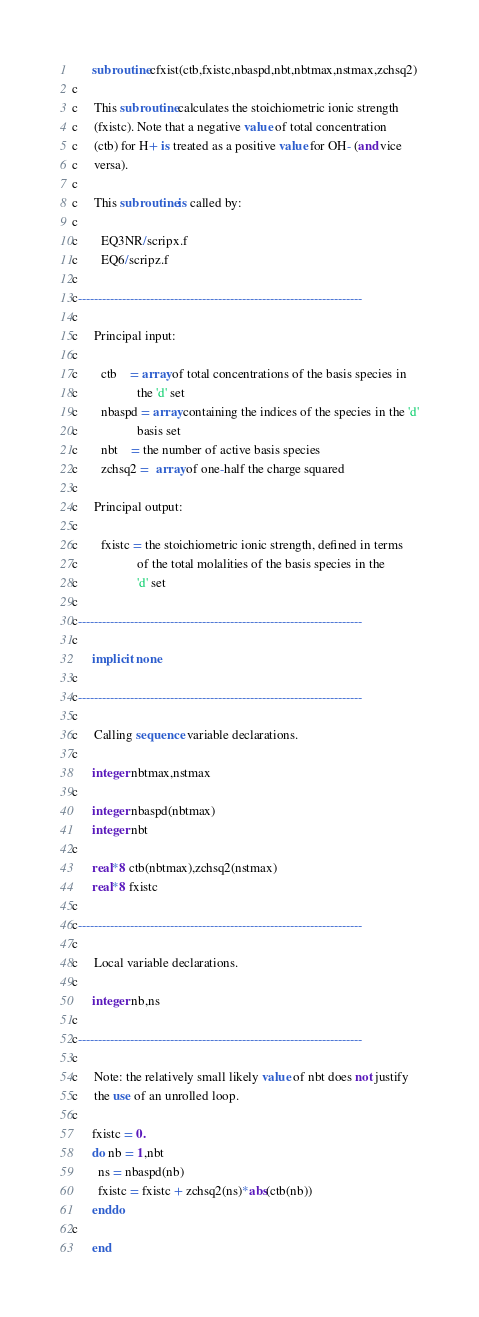<code> <loc_0><loc_0><loc_500><loc_500><_FORTRAN_>      subroutine cfxist(ctb,fxistc,nbaspd,nbt,nbtmax,nstmax,zchsq2)
c
c     This subroutine calculates the stoichiometric ionic strength
c     (fxistc). Note that a negative value of total concentration
c     (ctb) for H+ is treated as a positive value for OH- (and vice
c     versa).
c
c     This subroutine is called by:
c
c       EQ3NR/scripx.f
c       EQ6/scripz.f
c
c-----------------------------------------------------------------------
c
c     Principal input:
c
c       ctb    = array of total concentrations of the basis species in
c                  the 'd' set
c       nbaspd = array containing the indices of the species in the 'd'
c                  basis set
c       nbt    = the number of active basis species
c       zchsq2 =  array of one-half the charge squared
c
c     Principal output:
c
c       fxistc = the stoichiometric ionic strength, defined in terms
c                  of the total molalities of the basis species in the
c                  'd' set
c
c-----------------------------------------------------------------------
c
      implicit none
c
c-----------------------------------------------------------------------
c
c     Calling sequence variable declarations.
c
      integer nbtmax,nstmax
c
      integer nbaspd(nbtmax)
      integer nbt
c
      real*8 ctb(nbtmax),zchsq2(nstmax)
      real*8 fxistc
c
c-----------------------------------------------------------------------
c
c     Local variable declarations.
c
      integer nb,ns
c
c-----------------------------------------------------------------------
c
c     Note: the relatively small likely value of nbt does not justify
c     the use of an unrolled loop.
c
      fxistc = 0.
      do nb = 1,nbt
        ns = nbaspd(nb)
        fxistc = fxistc + zchsq2(ns)*abs(ctb(nb))
      enddo
c
      end
</code> 